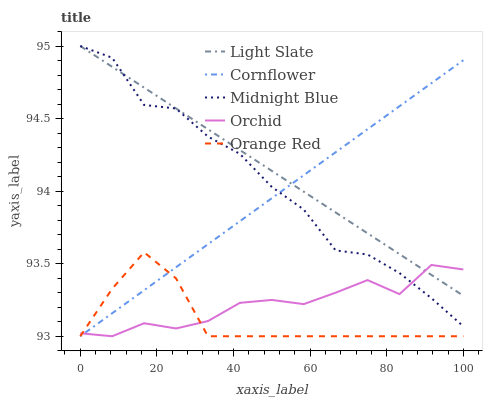Does Cornflower have the minimum area under the curve?
Answer yes or no. No. Does Cornflower have the maximum area under the curve?
Answer yes or no. No. Is Cornflower the smoothest?
Answer yes or no. No. Is Cornflower the roughest?
Answer yes or no. No. Does Midnight Blue have the lowest value?
Answer yes or no. No. Does Cornflower have the highest value?
Answer yes or no. No. Is Orange Red less than Light Slate?
Answer yes or no. Yes. Is Light Slate greater than Orange Red?
Answer yes or no. Yes. Does Orange Red intersect Light Slate?
Answer yes or no. No. 